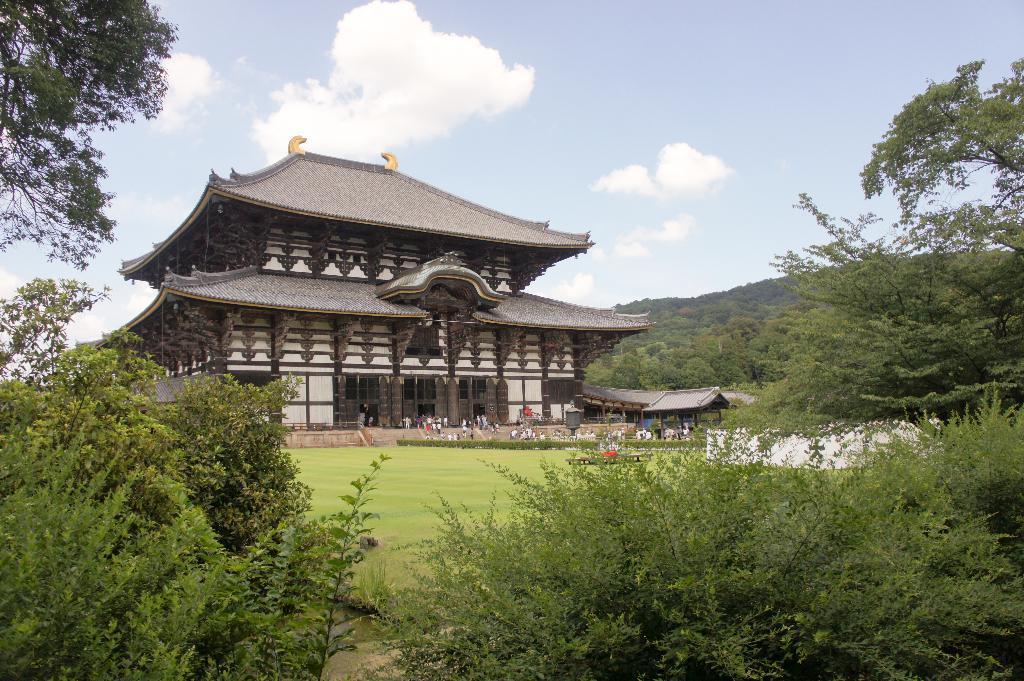Describe this image in one or two sentences. In the center of the image, we can see a building and there are sheds and we can see people. In the background, there are trees, hills and there are plants. At the top, there are clouds in the sky and at the bottom, there is ground. 